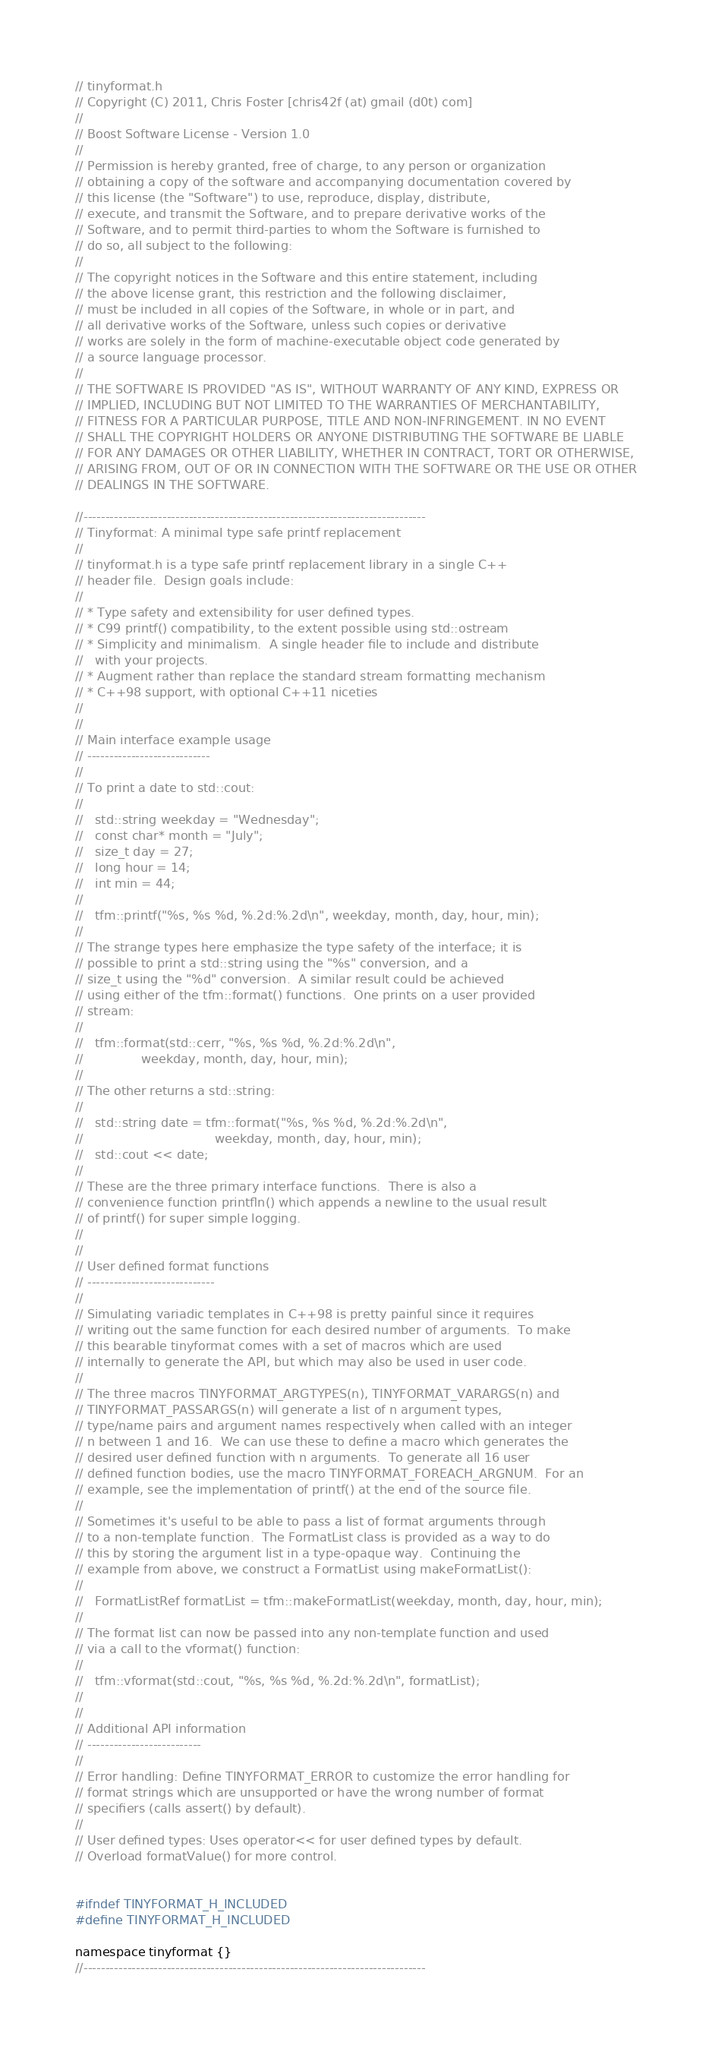Convert code to text. <code><loc_0><loc_0><loc_500><loc_500><_C_>// tinyformat.h
// Copyright (C) 2011, Chris Foster [chris42f (at) gmail (d0t) com]
//
// Boost Software License - Version 1.0
//
// Permission is hereby granted, free of charge, to any person or organization
// obtaining a copy of the software and accompanying documentation covered by
// this license (the "Software") to use, reproduce, display, distribute,
// execute, and transmit the Software, and to prepare derivative works of the
// Software, and to permit third-parties to whom the Software is furnished to
// do so, all subject to the following:
//
// The copyright notices in the Software and this entire statement, including
// the above license grant, this restriction and the following disclaimer,
// must be included in all copies of the Software, in whole or in part, and
// all derivative works of the Software, unless such copies or derivative
// works are solely in the form of machine-executable object code generated by
// a source language processor.
//
// THE SOFTWARE IS PROVIDED "AS IS", WITHOUT WARRANTY OF ANY KIND, EXPRESS OR
// IMPLIED, INCLUDING BUT NOT LIMITED TO THE WARRANTIES OF MERCHANTABILITY,
// FITNESS FOR A PARTICULAR PURPOSE, TITLE AND NON-INFRINGEMENT. IN NO EVENT
// SHALL THE COPYRIGHT HOLDERS OR ANYONE DISTRIBUTING THE SOFTWARE BE LIABLE
// FOR ANY DAMAGES OR OTHER LIABILITY, WHETHER IN CONTRACT, TORT OR OTHERWISE,
// ARISING FROM, OUT OF OR IN CONNECTION WITH THE SOFTWARE OR THE USE OR OTHER
// DEALINGS IN THE SOFTWARE.

//------------------------------------------------------------------------------
// Tinyformat: A minimal type safe printf replacement
//
// tinyformat.h is a type safe printf replacement library in a single C++
// header file.  Design goals include:
//
// * Type safety and extensibility for user defined types.
// * C99 printf() compatibility, to the extent possible using std::ostream
// * Simplicity and minimalism.  A single header file to include and distribute
//   with your projects.
// * Augment rather than replace the standard stream formatting mechanism
// * C++98 support, with optional C++11 niceties
//
//
// Main interface example usage
// ----------------------------
//
// To print a date to std::cout:
//
//   std::string weekday = "Wednesday";
//   const char* month = "July";
//   size_t day = 27;
//   long hour = 14;
//   int min = 44;
//
//   tfm::printf("%s, %s %d, %.2d:%.2d\n", weekday, month, day, hour, min);
//
// The strange types here emphasize the type safety of the interface; it is
// possible to print a std::string using the "%s" conversion, and a
// size_t using the "%d" conversion.  A similar result could be achieved
// using either of the tfm::format() functions.  One prints on a user provided
// stream:
//
//   tfm::format(std::cerr, "%s, %s %d, %.2d:%.2d\n",
//               weekday, month, day, hour, min);
//
// The other returns a std::string:
//
//   std::string date = tfm::format("%s, %s %d, %.2d:%.2d\n",
//                                  weekday, month, day, hour, min);
//   std::cout << date;
//
// These are the three primary interface functions.  There is also a
// convenience function printfln() which appends a newline to the usual result
// of printf() for super simple logging.
//
//
// User defined format functions
// -----------------------------
//
// Simulating variadic templates in C++98 is pretty painful since it requires
// writing out the same function for each desired number of arguments.  To make
// this bearable tinyformat comes with a set of macros which are used
// internally to generate the API, but which may also be used in user code.
//
// The three macros TINYFORMAT_ARGTYPES(n), TINYFORMAT_VARARGS(n) and
// TINYFORMAT_PASSARGS(n) will generate a list of n argument types,
// type/name pairs and argument names respectively when called with an integer
// n between 1 and 16.  We can use these to define a macro which generates the
// desired user defined function with n arguments.  To generate all 16 user
// defined function bodies, use the macro TINYFORMAT_FOREACH_ARGNUM.  For an
// example, see the implementation of printf() at the end of the source file.
//
// Sometimes it's useful to be able to pass a list of format arguments through
// to a non-template function.  The FormatList class is provided as a way to do
// this by storing the argument list in a type-opaque way.  Continuing the
// example from above, we construct a FormatList using makeFormatList():
//
//   FormatListRef formatList = tfm::makeFormatList(weekday, month, day, hour, min);
//
// The format list can now be passed into any non-template function and used
// via a call to the vformat() function:
//
//   tfm::vformat(std::cout, "%s, %s %d, %.2d:%.2d\n", formatList);
//
//
// Additional API information
// --------------------------
//
// Error handling: Define TINYFORMAT_ERROR to customize the error handling for
// format strings which are unsupported or have the wrong number of format
// specifiers (calls assert() by default).
//
// User defined types: Uses operator<< for user defined types by default.
// Overload formatValue() for more control.


#ifndef TINYFORMAT_H_INCLUDED
#define TINYFORMAT_H_INCLUDED

namespace tinyformat {}
//------------------------------------------------------------------------------</code> 